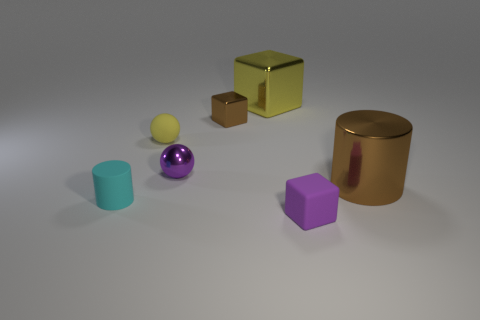What shape is the large yellow object?
Offer a terse response. Cube. What is the shape of the large object left of the small object in front of the cyan cylinder?
Offer a terse response. Cube. Do the purple object that is behind the tiny purple block and the large yellow object have the same material?
Offer a very short reply. Yes. How many cyan objects are either tiny rubber things or metal blocks?
Make the answer very short. 1. Is there another ball of the same color as the shiny sphere?
Provide a short and direct response. No. Is there a large thing made of the same material as the brown cylinder?
Keep it short and to the point. Yes. The object that is behind the small purple sphere and right of the tiny brown shiny cube has what shape?
Give a very brief answer. Cube. How many small objects are brown cylinders or balls?
Provide a short and direct response. 2. What material is the purple sphere?
Your response must be concise. Metal. How many other objects are the same shape as the purple matte thing?
Your response must be concise. 2. 